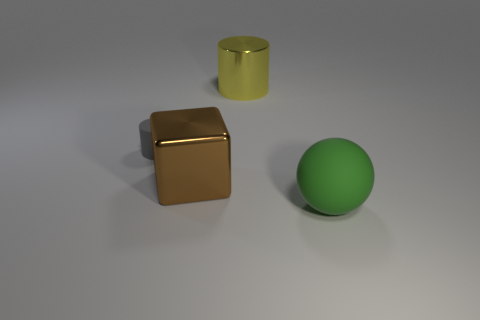Add 1 large brown things. How many objects exist? 5 Subtract all blocks. How many objects are left? 3 Subtract 1 gray cylinders. How many objects are left? 3 Subtract all large green rubber objects. Subtract all rubber objects. How many objects are left? 1 Add 4 large yellow metal cylinders. How many large yellow metal cylinders are left? 5 Add 2 metal cylinders. How many metal cylinders exist? 3 